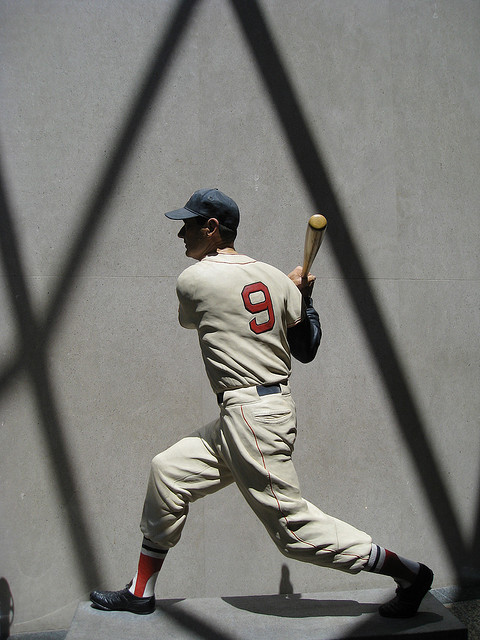Identify and read out the text in this image. 9 